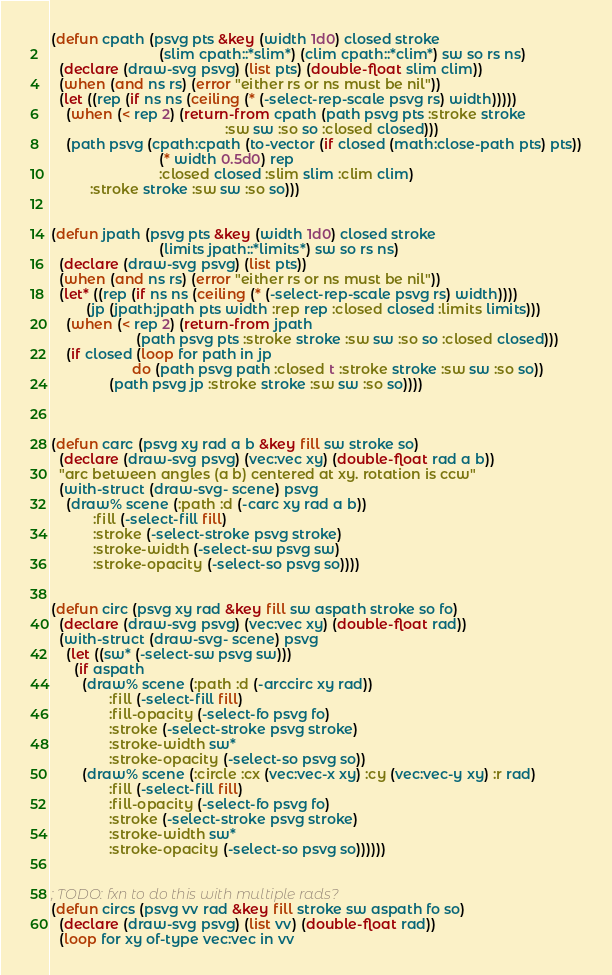Convert code to text. <code><loc_0><loc_0><loc_500><loc_500><_Lisp_>
(defun cpath (psvg pts &key (width 1d0) closed stroke
                            (slim cpath::*slim*) (clim cpath::*clim*) sw so rs ns)
  (declare (draw-svg psvg) (list pts) (double-float slim clim))
  (when (and ns rs) (error "either rs or ns must be nil"))
  (let ((rep (if ns ns (ceiling (* (-select-rep-scale psvg rs) width)))))
    (when (< rep 2) (return-from cpath (path psvg pts :stroke stroke
                                             :sw sw :so so :closed closed)))
    (path psvg (cpath:cpath (to-vector (if closed (math:close-path pts) pts))
                            (* width 0.5d0) rep
                            :closed closed :slim slim :clim clim)
          :stroke stroke :sw sw :so so)))


(defun jpath (psvg pts &key (width 1d0) closed stroke
                            (limits jpath::*limits*) sw so rs ns)
  (declare (draw-svg psvg) (list pts))
  (when (and ns rs) (error "either rs or ns must be nil"))
  (let* ((rep (if ns ns (ceiling (* (-select-rep-scale psvg rs) width))))
         (jp (jpath:jpath pts width :rep rep :closed closed :limits limits)))
    (when (< rep 2) (return-from jpath
                      (path psvg pts :stroke stroke :sw sw :so so :closed closed)))
    (if closed (loop for path in jp
                     do (path psvg path :closed t :stroke stroke :sw sw :so so))
               (path psvg jp :stroke stroke :sw sw :so so))))



(defun carc (psvg xy rad a b &key fill sw stroke so)
  (declare (draw-svg psvg) (vec:vec xy) (double-float rad a b))
  "arc between angles (a b) centered at xy. rotation is ccw"
  (with-struct (draw-svg- scene) psvg
    (draw% scene (:path :d (-carc xy rad a b))
           :fill (-select-fill fill)
           :stroke (-select-stroke psvg stroke)
           :stroke-width (-select-sw psvg sw)
           :stroke-opacity (-select-so psvg so))))


(defun circ (psvg xy rad &key fill sw aspath stroke so fo)
  (declare (draw-svg psvg) (vec:vec xy) (double-float rad))
  (with-struct (draw-svg- scene) psvg
    (let ((sw* (-select-sw psvg sw)))
      (if aspath
        (draw% scene (:path :d (-arccirc xy rad))
               :fill (-select-fill fill)
               :fill-opacity (-select-fo psvg fo)
               :stroke (-select-stroke psvg stroke)
               :stroke-width sw*
               :stroke-opacity (-select-so psvg so))
        (draw% scene (:circle :cx (vec:vec-x xy) :cy (vec:vec-y xy) :r rad)
               :fill (-select-fill fill)
               :fill-opacity (-select-fo psvg fo)
               :stroke (-select-stroke psvg stroke)
               :stroke-width sw*
               :stroke-opacity (-select-so psvg so))))))


; TODO: fxn to do this with multiple rads?
(defun circs (psvg vv rad &key fill stroke sw aspath fo so)
  (declare (draw-svg psvg) (list vv) (double-float rad))
  (loop for xy of-type vec:vec in vv</code> 